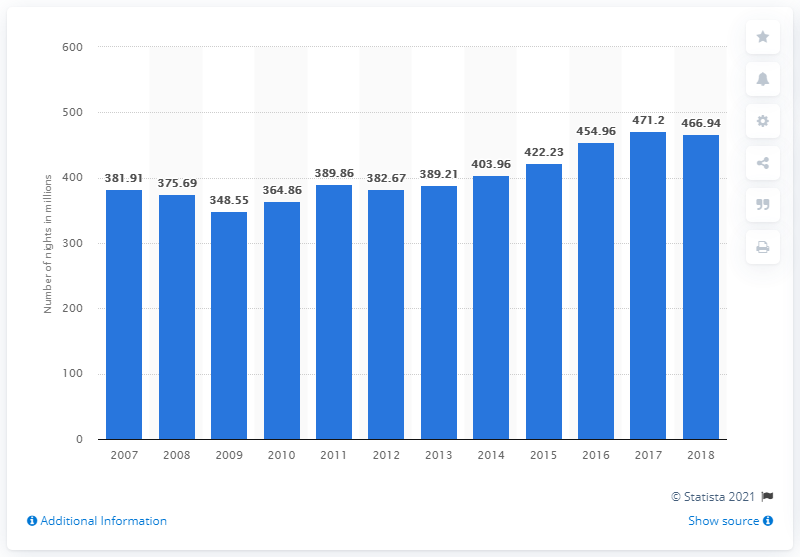Outline some significant characteristics in this image. During the period of 2007 to 2018, a total of 466.94 nights were spent at tourist accommodation establishments. 